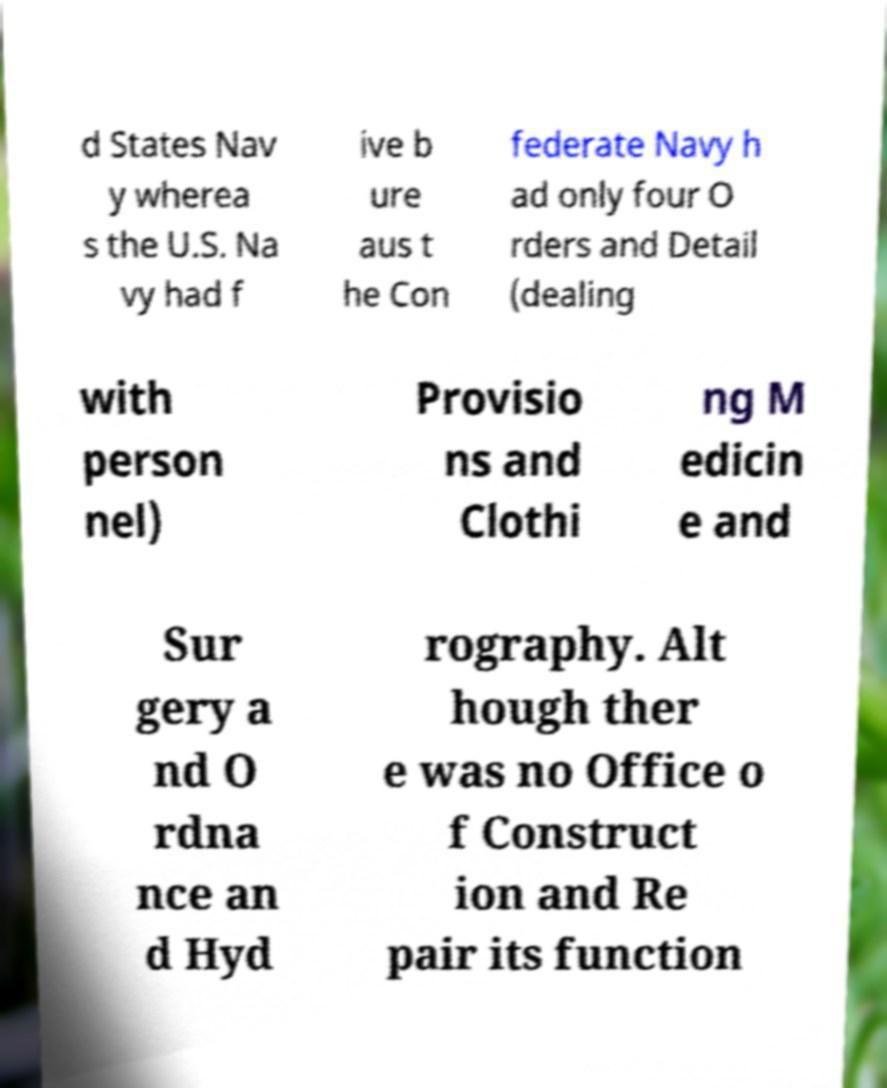Please read and relay the text visible in this image. What does it say? d States Nav y wherea s the U.S. Na vy had f ive b ure aus t he Con federate Navy h ad only four O rders and Detail (dealing with person nel) Provisio ns and Clothi ng M edicin e and Sur gery a nd O rdna nce an d Hyd rography. Alt hough ther e was no Office o f Construct ion and Re pair its function 